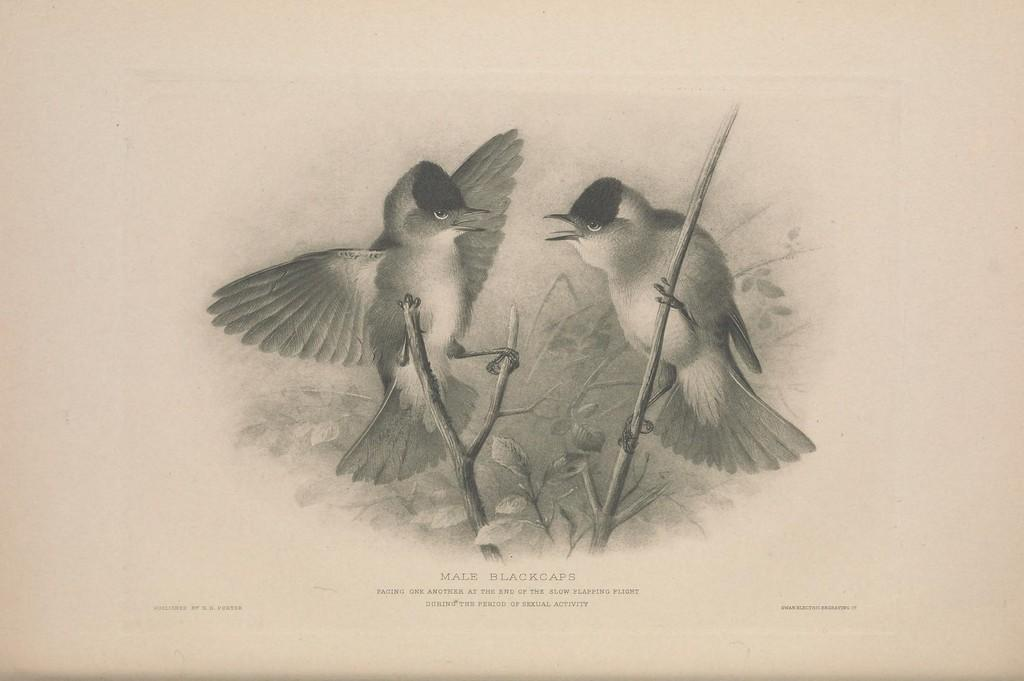What is the main subject of the image? There is a painting in the image. What can be seen in the painting? The painting contains birds on branches with leaves. Is there any text associated with the painting? Yes, there is text at the bottom of the painting. What type of bag is being used to create the painting in the image? There is no bag present in the image, and the painting is not being created in the image. --- Facts: 1. There is a person sitting on a bench in the image. 2. The person is reading a book. 3. There is a tree behind the bench. 4. The sky is visible in the image. Absurd Topics: parrot, bicycle, ocean Conversation: What is the person in the image doing? The person is sitting on a bench in the image. What activity is the person engaged in while sitting on the bench? The person is reading a book. What can be seen behind the bench in the image? There is a tree behind the bench. What is visible in the background of the image? The sky is visible in the image. Reasoning: Let's think step by step in order to produce the conversation. We start by identifying the main subject of the image, which is the person sitting on the bench. Then, we describe the activity the person is engaged in, which is reading a book. Next, we mention the presence of a tree behind the bench and the visibility of the sky in the background. Absurd Question/Answer: Can you see a parrot flying over the ocean in the image? There is no parrot or ocean present in the image. --- Facts: 1. There is a group of people standing in a circle in the image. 2. The people are holding hands. 3. There is a sign in the center of the circle. 4. The sign has text on it. Absurd Topics: elephant, fire, mountain Conversation: What is happening in the image? There is a group of people standing in a circle in the image. What are the people doing while standing in the circle? The people are holding hands. What can be seen in the center of the circle? There is a sign in the center of the circle. What information is provided on the sign? The sign has text on it. Reasoning: Let's think step by step in order to produce the conversation. We start by identifying the main subject of the image, which is the group of people standing in a circle. Then, we describe the action the people are engaged in, which is holding hands. Next, we mention the presence of a sign in the center of the circle and the text on the sign. Absurd Question/Answer: Can you see an elephant jumping over a mountain in the image? There is no elephant or mountain present in the image. 